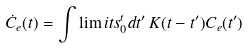Convert formula to latex. <formula><loc_0><loc_0><loc_500><loc_500>\dot { C } _ { e } ( t ) = \int \lim i t s _ { 0 } ^ { t } d t ^ { \prime } \, K ( t - t ^ { \prime } ) C _ { e } ( t ^ { \prime } )</formula> 